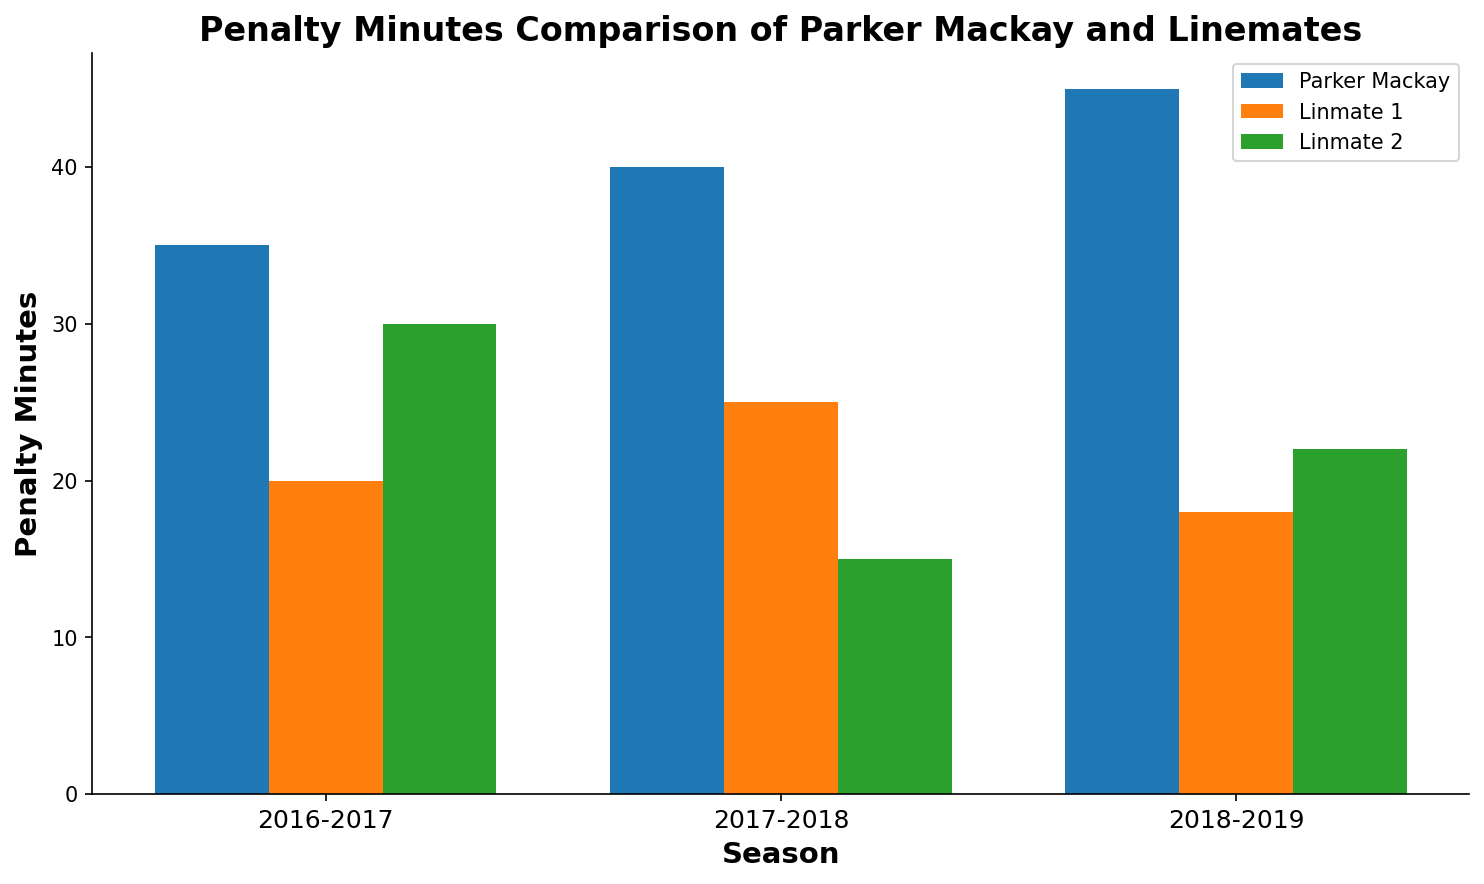Which season did Parker Mackay have the most penalty minutes? By examining the height of the bars representing Parker Mackay across the seasons, the tallest bar corresponds to the 2018-2019 season.
Answer: 2018-2019 Which player had the lowest penalty minutes in the 2017-2018 season? From the bars representing the 2017-2018 season, Linemate 2 had the lowest bar, indicating the lowest penalty minutes.
Answer: Linemate 2 What is the total penalty minutes for Parker Mackay over all three seasons? Adding Parker Mackay's penalty minutes for each season: 35 (2016-2017) + 40 (2017-2018) + 45 (2018-2019) results in 120 penalty minutes.
Answer: 120 In which season did Linemate 1 receive fewer penalty minutes than both Parker Mackay and Linemate 2? By comparing the bars for Linemate 1, Parker Mackay, and Linemate 2 for each season, Linemate 1 had fewer penalty minutes in both 2017-2018 and 2018-2019.
Answer: 2017-2018, 2018-2019 Which season shows the smallest difference in penalty minutes between Parker Mackay and his linemates combined? Calculating differences: 2016-2017 (35 - (20+30) = -15), 2017-2018 (40 - (25+15) = 0), 2018-2019 (45 - (18+22) = 5), the smallest difference is in 2017-2018, which is 0.
Answer: 2017-2018 What is the average penalty minutes for Linemate 2 over the three seasons? Summing Linemate 2's penalty minutes (30 + 15 + 22) = 67 and dividing by 3 seasons results in an average of 22.33.
Answer: 22.33 Is the penalty trend for Parker Mackay increasing, decreasing, or stable over the three seasons? Observing the heights of Parker Mackay's bars across the seasons, they consistently increase from 35 to 40 to 45.
Answer: Increasing What is the difference in penalty minutes between Parker Mackay and Linemate 1 in the 2016-2017 and 2018-2019 seasons combined? Calculating differences: 2016-2017 (35 - 20 = 15), 2018-2019 (45 - 18 = 27); summing the differences results in 15 + 27 = 42.
Answer: 42 